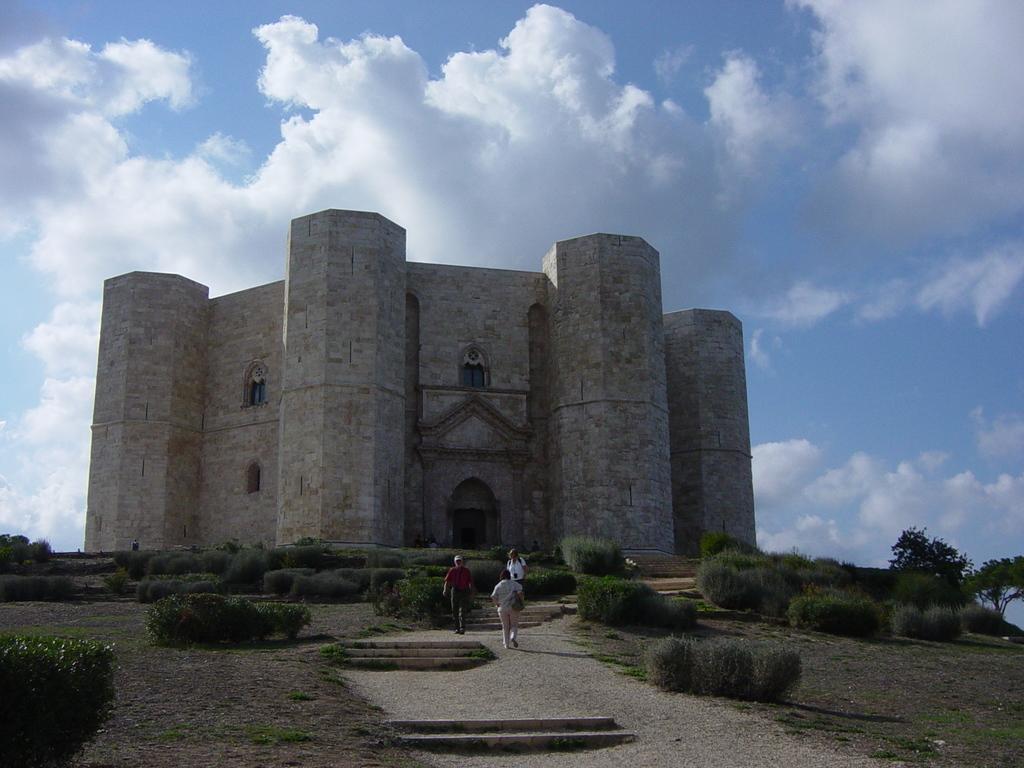Please provide a concise description of this image. In the we can see there are people standing on the ground and behind there is a building. There are plants and bushes on the ground. There is a cloudy sky. 